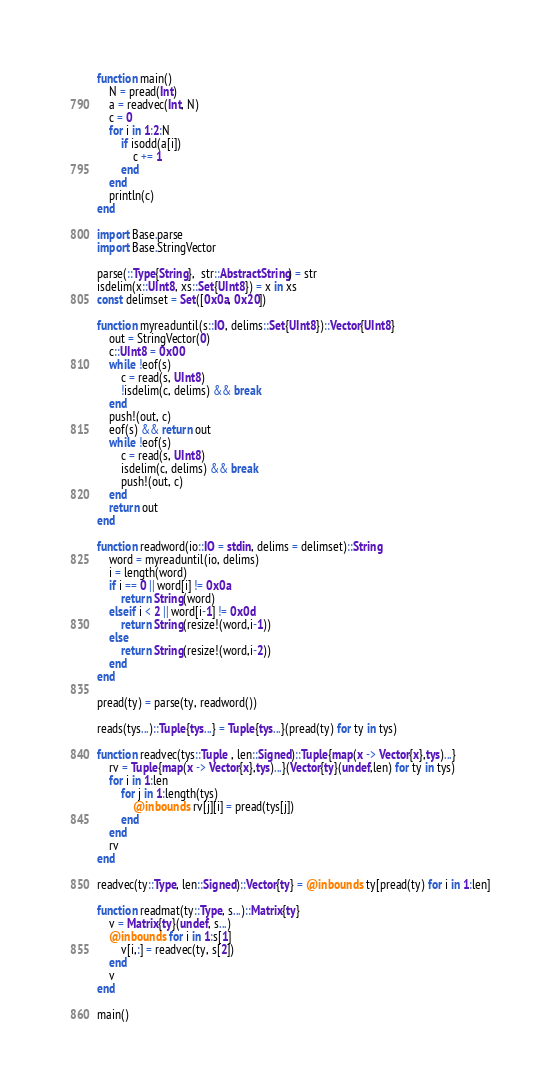Convert code to text. <code><loc_0><loc_0><loc_500><loc_500><_Julia_>function main()
    N = pread(Int)
    a = readvec(Int, N)
    c = 0
    for i in 1:2:N
        if isodd(a[i])
            c += 1
        end
    end
    println(c)
end

import Base.parse
import Base.StringVector

parse(::Type{String},  str::AbstractString) = str
isdelim(x::UInt8, xs::Set{UInt8}) = x in xs
const delimset = Set([0x0a, 0x20])

function myreaduntil(s::IO, delims::Set{UInt8})::Vector{UInt8}
    out = StringVector(0)
    c::UInt8 = 0x00
    while !eof(s)
        c = read(s, UInt8)
        !isdelim(c, delims) && break
    end
    push!(out, c)
    eof(s) && return out
    while !eof(s)
        c = read(s, UInt8)
        isdelim(c, delims) && break
        push!(out, c)
    end
    return out
end

function readword(io::IO = stdin, delims = delimset)::String
    word = myreaduntil(io, delims)
    i = length(word)
    if i == 0 || word[i] != 0x0a
        return String(word)
    elseif i < 2 || word[i-1] != 0x0d
        return String(resize!(word,i-1))
    else
        return String(resize!(word,i-2))
    end
end

pread(ty) = parse(ty, readword())

reads(tys...)::Tuple{tys...} = Tuple{tys...}(pread(ty) for ty in tys)

function readvec(tys::Tuple , len::Signed)::Tuple{map(x -> Vector{x},tys)...}
    rv = Tuple{map(x -> Vector{x},tys)...}(Vector{ty}(undef,len) for ty in tys)
    for i in 1:len
        for j in 1:length(tys)
            @inbounds rv[j][i] = pread(tys[j])
        end
    end
    rv
end

readvec(ty::Type, len::Signed)::Vector{ty} = @inbounds ty[pread(ty) for i in 1:len]

function readmat(ty::Type, s...)::Matrix{ty}
    v = Matrix{ty}(undef, s...)
    @inbounds for i in 1:s[1]
        v[i,:] = readvec(ty, s[2])
    end
    v
end

main()
</code> 